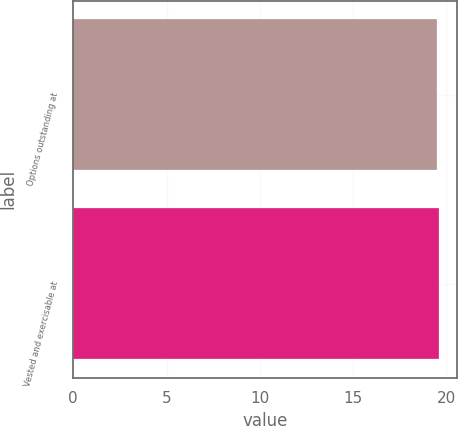Convert chart. <chart><loc_0><loc_0><loc_500><loc_500><bar_chart><fcel>Options outstanding at<fcel>Vested and exercisable at<nl><fcel>19.49<fcel>19.59<nl></chart> 